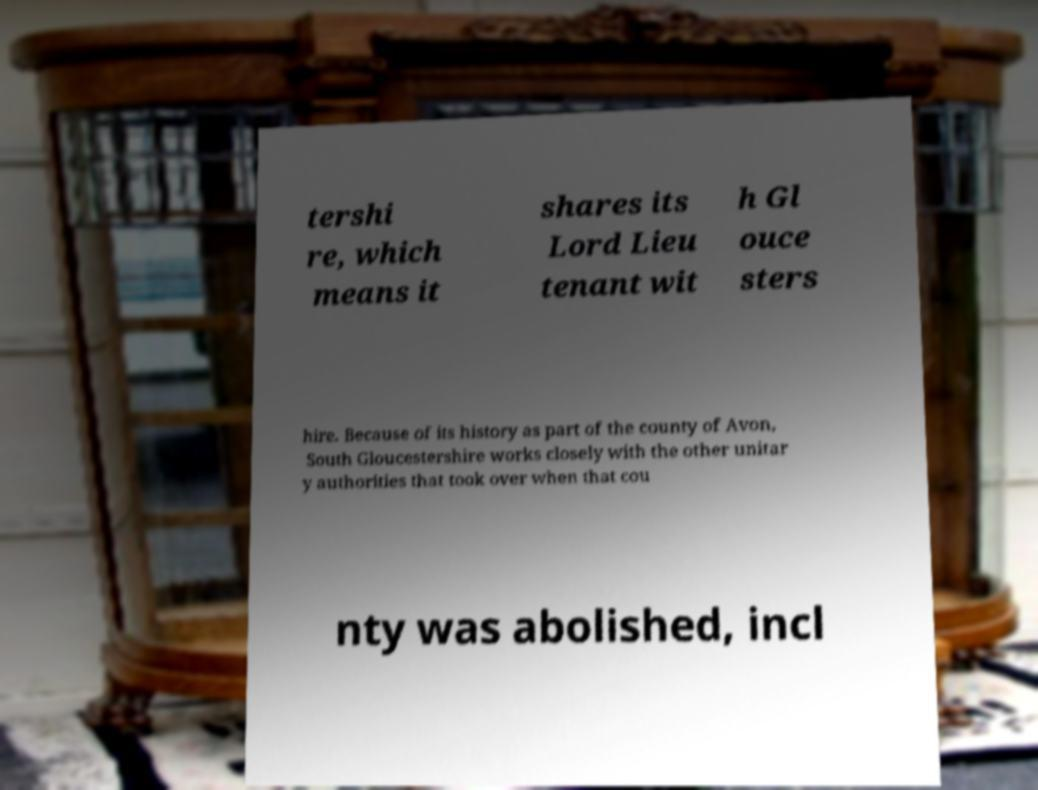For documentation purposes, I need the text within this image transcribed. Could you provide that? tershi re, which means it shares its Lord Lieu tenant wit h Gl ouce sters hire. Because of its history as part of the county of Avon, South Gloucestershire works closely with the other unitar y authorities that took over when that cou nty was abolished, incl 